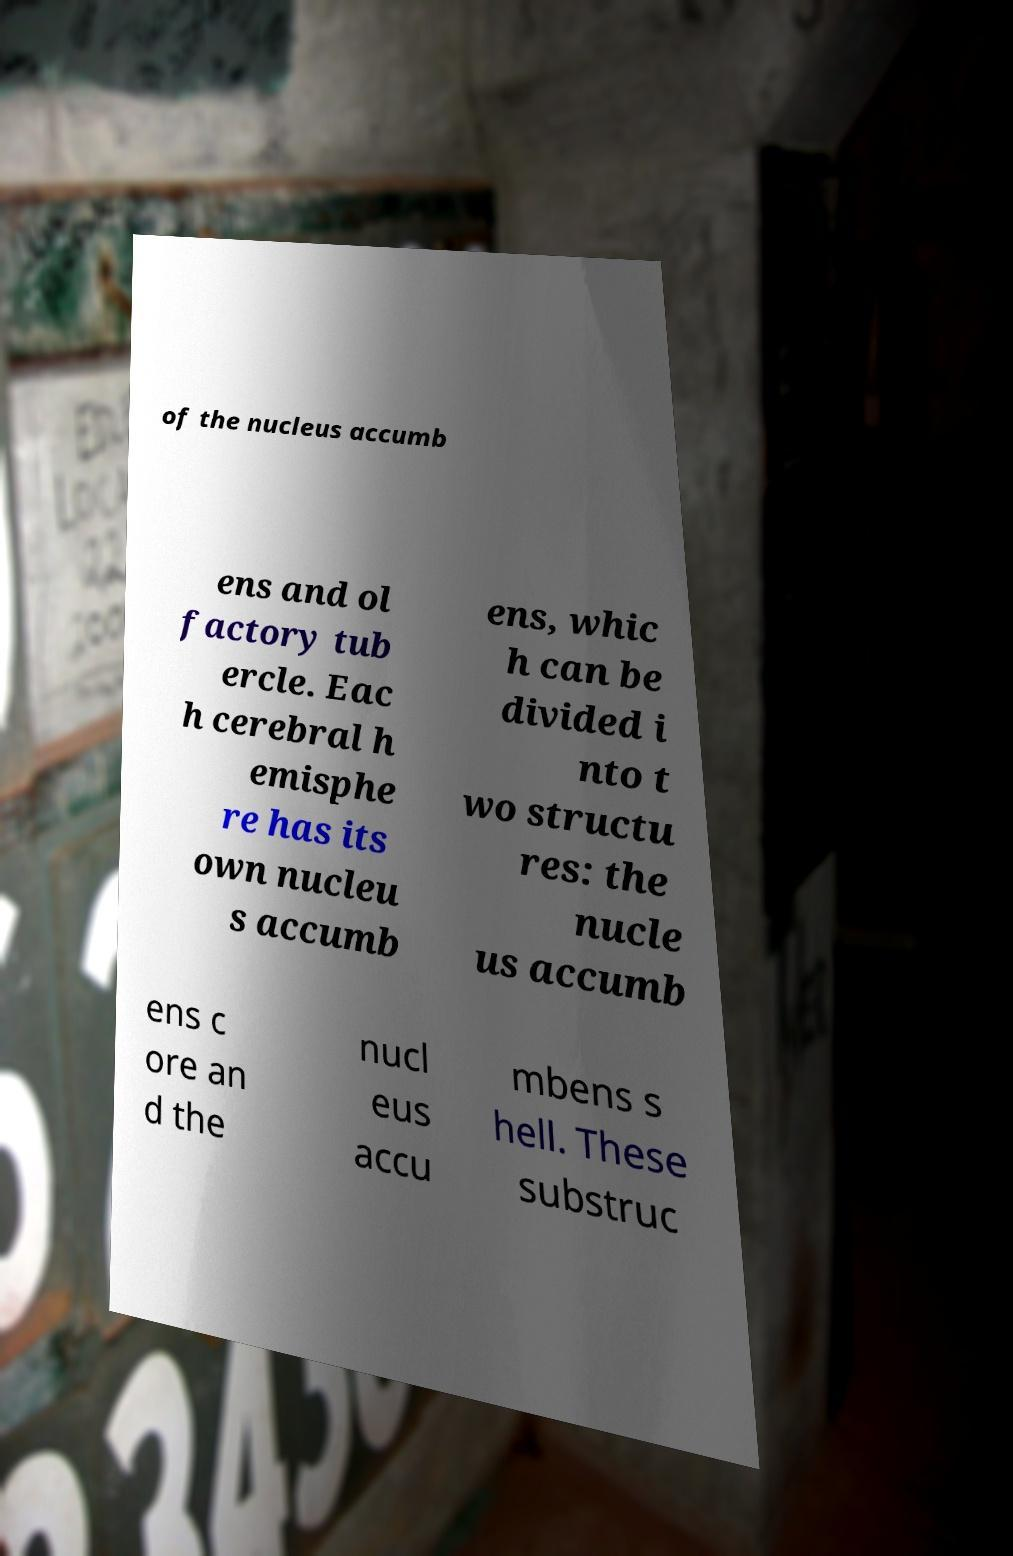Please read and relay the text visible in this image. What does it say? of the nucleus accumb ens and ol factory tub ercle. Eac h cerebral h emisphe re has its own nucleu s accumb ens, whic h can be divided i nto t wo structu res: the nucle us accumb ens c ore an d the nucl eus accu mbens s hell. These substruc 